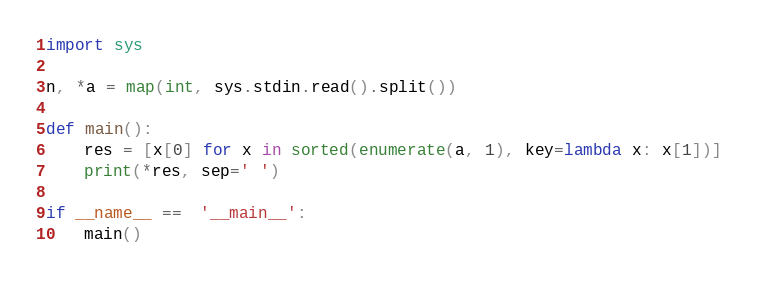<code> <loc_0><loc_0><loc_500><loc_500><_Python_>import sys

n, *a = map(int, sys.stdin.read().split())

def main():
    res = [x[0] for x in sorted(enumerate(a, 1), key=lambda x: x[1])]
    print(*res, sep=' ')

if __name__ ==  '__main__':
    main()</code> 